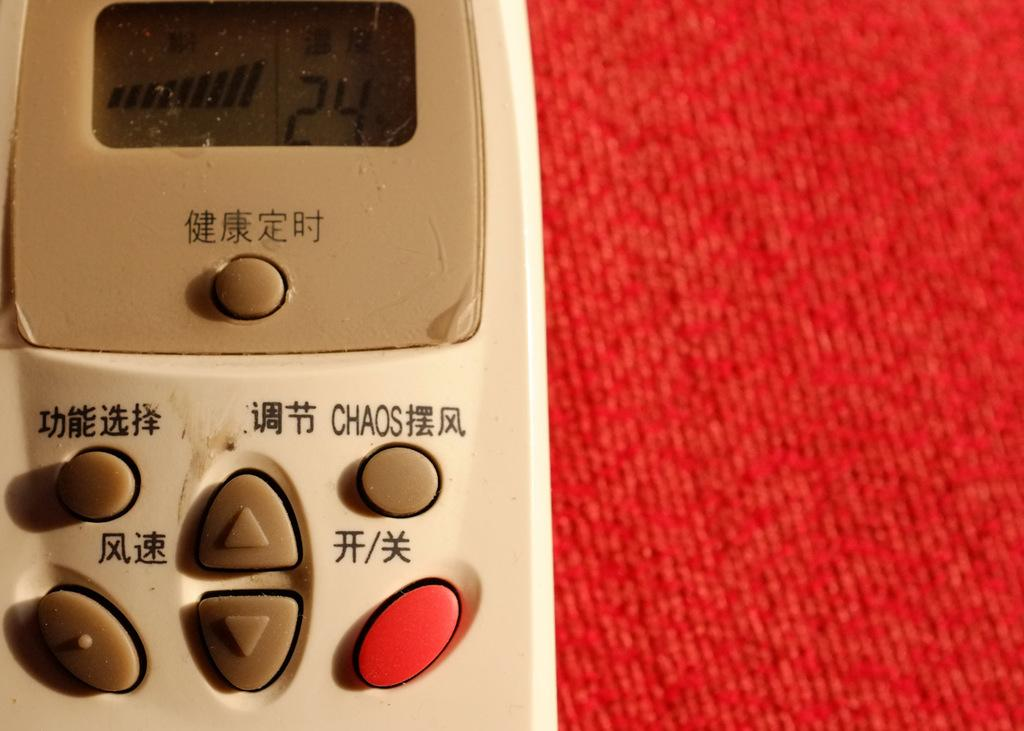Provide a one-sentence caption for the provided image. A remote that has Chinese letters on it and the word Chaos. 